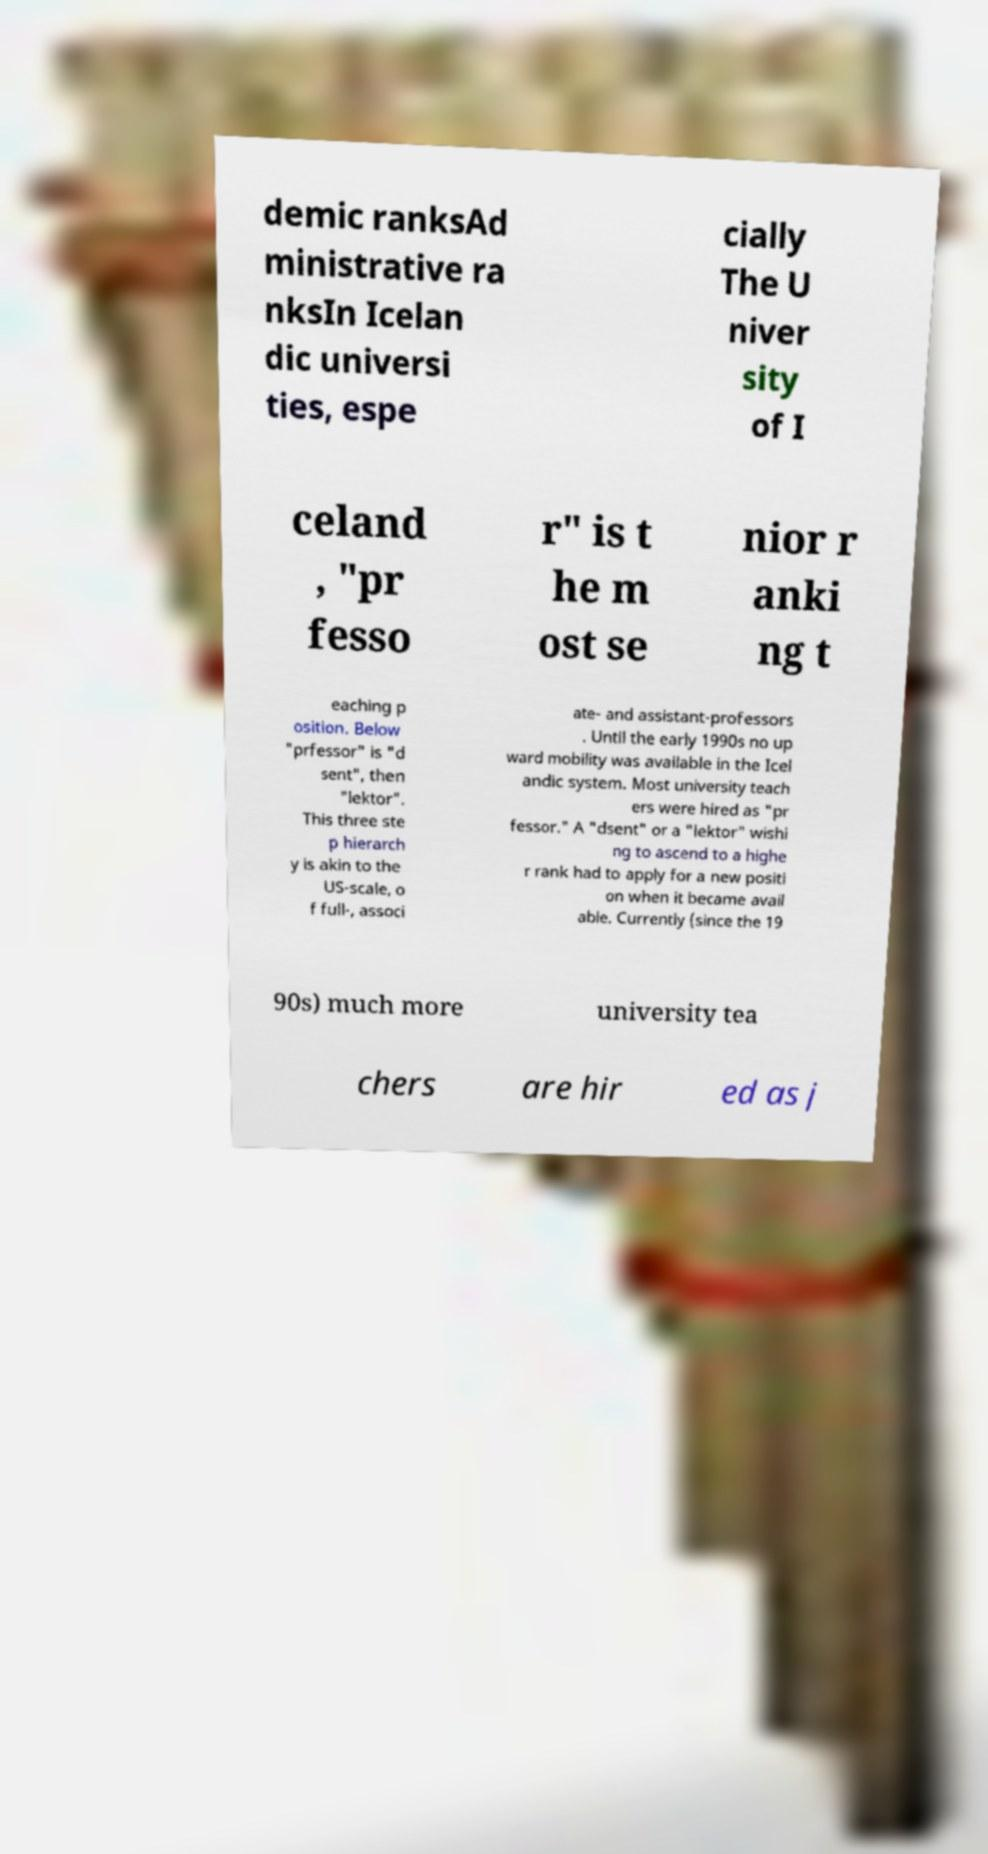Please identify and transcribe the text found in this image. demic ranksAd ministrative ra nksIn Icelan dic universi ties, espe cially The U niver sity of I celand , "pr fesso r" is t he m ost se nior r anki ng t eaching p osition. Below "prfessor" is "d sent", then "lektor". This three ste p hierarch y is akin to the US-scale, o f full-, associ ate- and assistant-professors . Until the early 1990s no up ward mobility was available in the Icel andic system. Most university teach ers were hired as "pr fessor." A "dsent" or a "lektor" wishi ng to ascend to a highe r rank had to apply for a new positi on when it became avail able. Currently (since the 19 90s) much more university tea chers are hir ed as j 